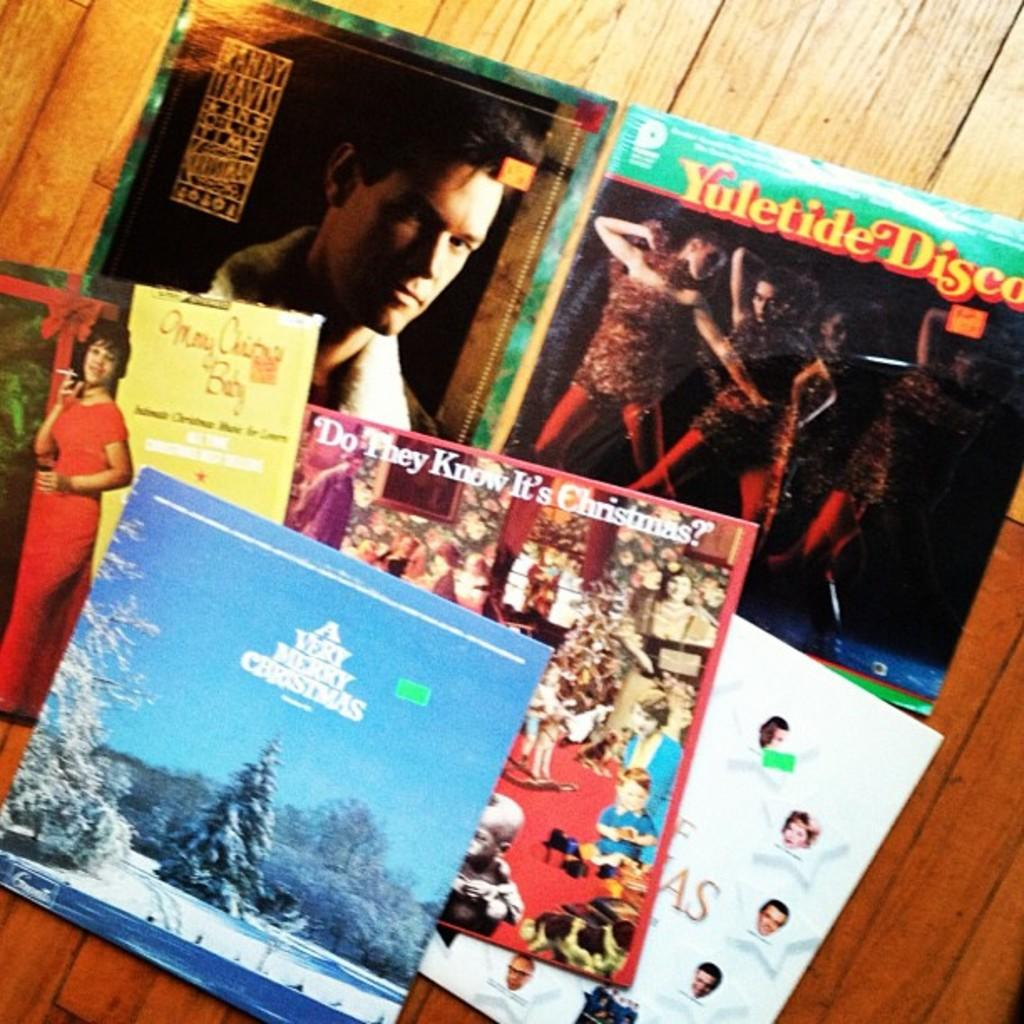<image>
Write a terse but informative summary of the picture. Vinyl Christmas record collection including A very merry Christmas. 